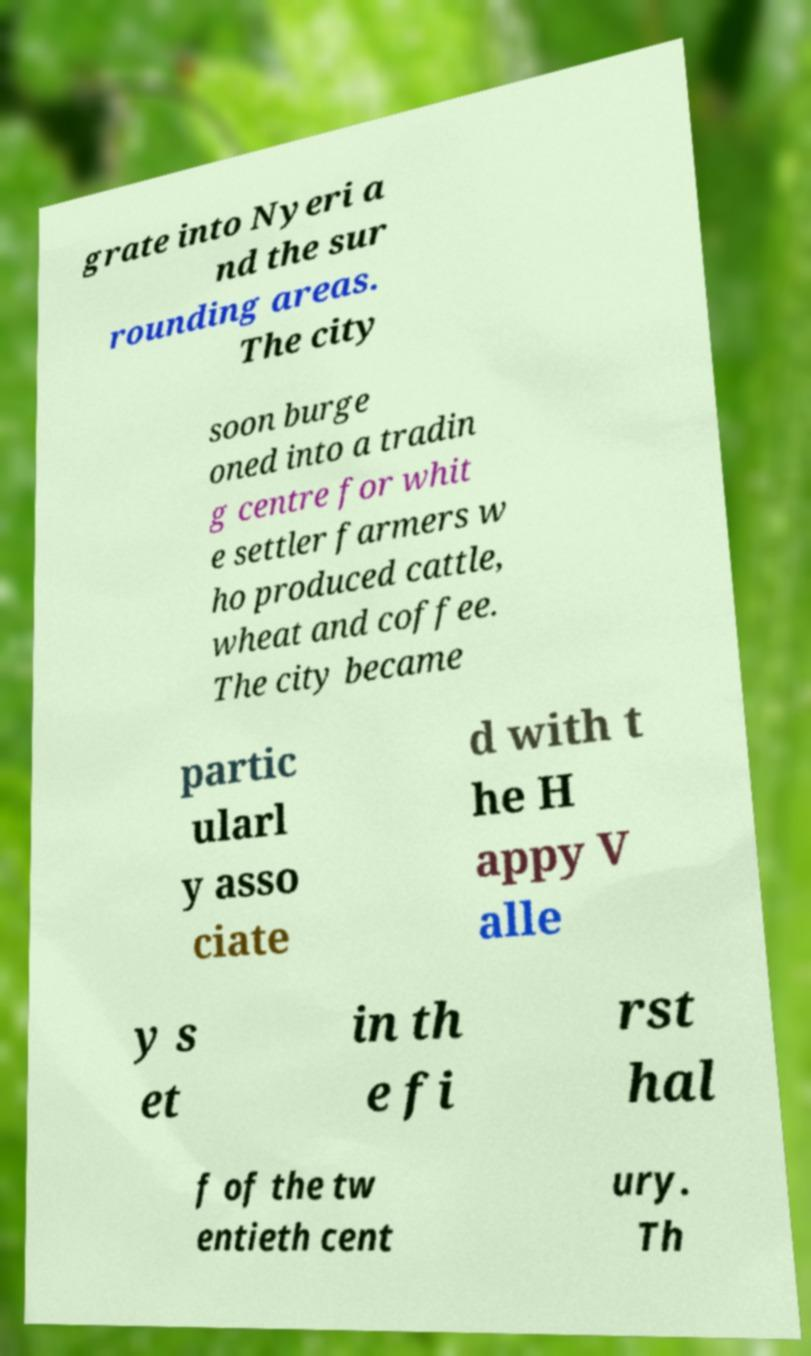Please read and relay the text visible in this image. What does it say? grate into Nyeri a nd the sur rounding areas. The city soon burge oned into a tradin g centre for whit e settler farmers w ho produced cattle, wheat and coffee. The city became partic ularl y asso ciate d with t he H appy V alle y s et in th e fi rst hal f of the tw entieth cent ury. Th 